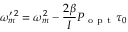Convert formula to latex. <formula><loc_0><loc_0><loc_500><loc_500>\omega _ { m } ^ { \prime \, 2 } = \omega _ { m } ^ { 2 } - \frac { 2 \beta } { I } P _ { o p t } \tau _ { 0 }</formula> 